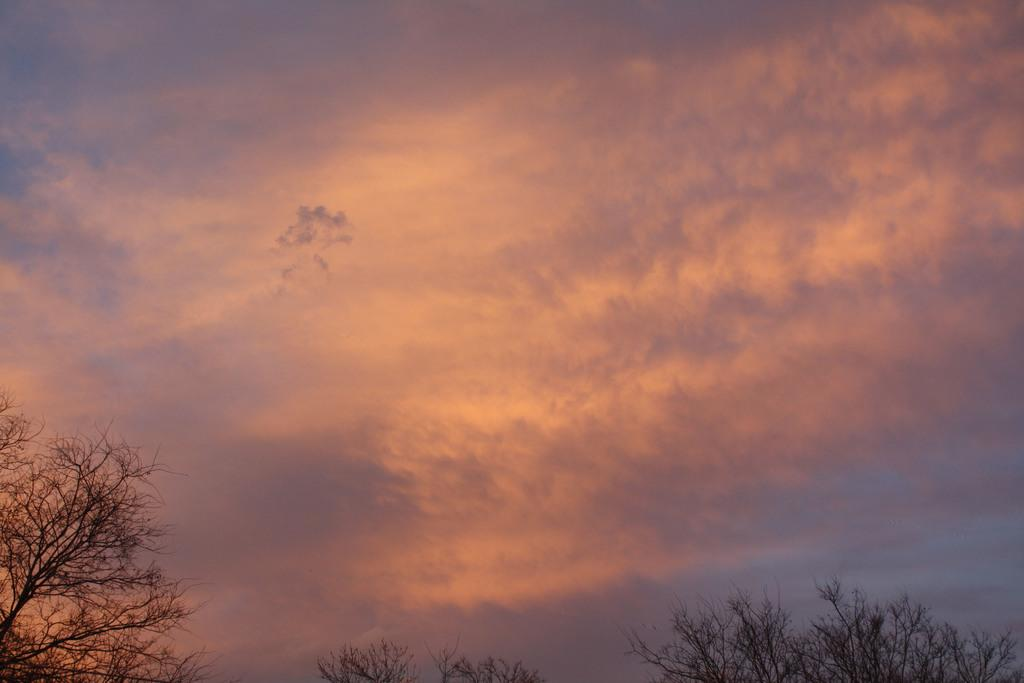What can be seen in the background of the image? The sky is visible in the image. What is present in the sky? Clouds are present in the image. What type of vegetation can be seen in the image? Trees are in the image. Can you tell me where the receipt is located in the image? There is no receipt present in the image. What type of wine can be seen in the image? There is no wine present in the image. 